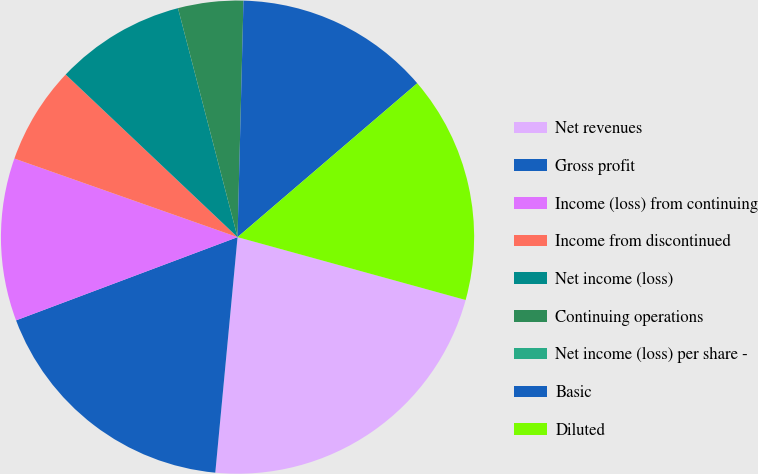Convert chart. <chart><loc_0><loc_0><loc_500><loc_500><pie_chart><fcel>Net revenues<fcel>Gross profit<fcel>Income (loss) from continuing<fcel>Income from discontinued<fcel>Net income (loss)<fcel>Continuing operations<fcel>Net income (loss) per share -<fcel>Basic<fcel>Diluted<nl><fcel>22.22%<fcel>17.78%<fcel>11.11%<fcel>6.67%<fcel>8.89%<fcel>4.45%<fcel>0.0%<fcel>13.33%<fcel>15.55%<nl></chart> 